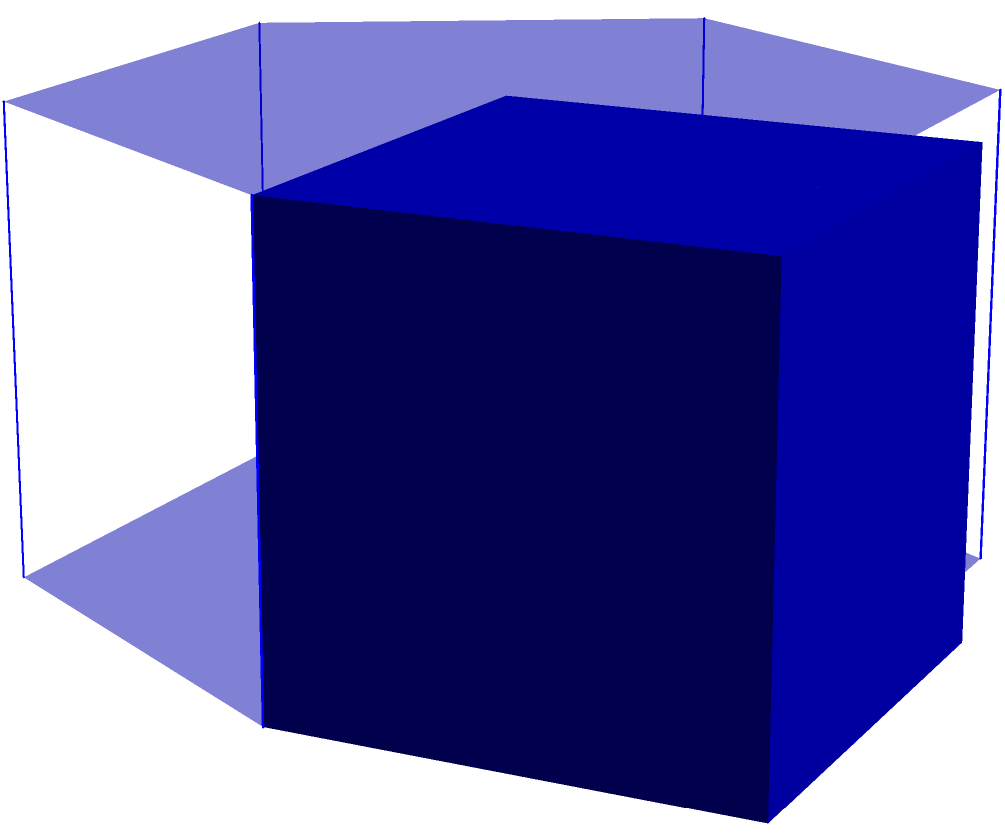In your latest molecular design project, you've created a hexagonal prism-like arrangement of atoms. The hexagonal base has a side length of $a$ nanometers, and the height of the prism is $h$ nanometers. If the total surface area of this molecular arrangement is 150 square nanometers, and the height is twice the side length of the hexagon, calculate the side length $a$ of the hexagonal base. Let's approach this step-by-step:

1) The surface area of a hexagonal prism consists of two hexagonal bases and six rectangular sides.

2) Area of a regular hexagon: $A_{hexagon} = \frac{3\sqrt{3}}{2}a^2$

3) Area of the rectangular sides: $A_{rectangles} = 6ah$

4) Total surface area: $A_{total} = 2A_{hexagon} + A_{rectangles}$

5) Substituting the formulas:
   $A_{total} = 2(\frac{3\sqrt{3}}{2}a^2) + 6ah$

6) We're given that $h = 2a$, so let's substitute this:
   $A_{total} = 3\sqrt{3}a^2 + 6a(2a) = 3\sqrt{3}a^2 + 12a^2$

7) We're also told that the total surface area is 150 nm²:
   $150 = 3\sqrt{3}a^2 + 12a^2$

8) Simplify:
   $150 = (3\sqrt{3} + 12)a^2$

9) Solve for $a$:
   $a^2 = \frac{150}{3\sqrt{3} + 12}$
   $a = \sqrt{\frac{150}{3\sqrt{3} + 12}}$

10) Calculate the value:
    $a \approx 2.89$ nm

Therefore, the side length of the hexagonal base is approximately 2.89 nanometers.
Answer: $a \approx 2.89$ nm 